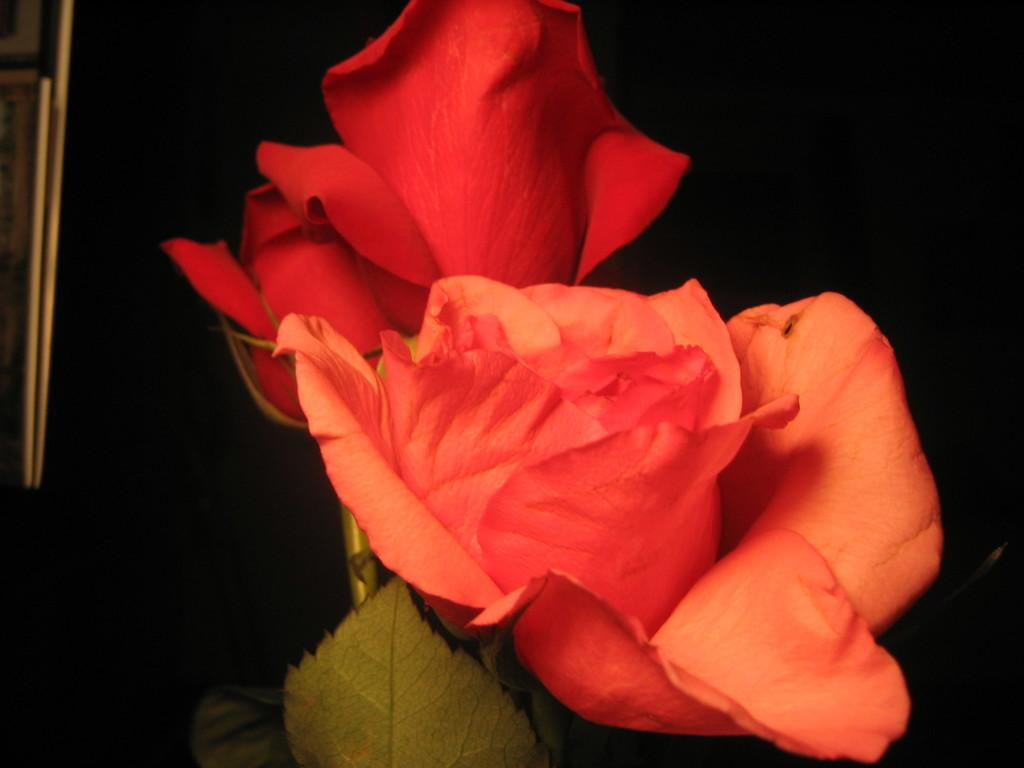What is the main subject in the center of the image? There are flowers in the center of the image. What can be seen on the left side of the image? There is a frame on the left side of the image. How would you describe the overall color scheme of the image? The background of the image is dark. What type of plot is visible in the image? There is no plot visible in the image; it features flowers and a frame. Can you see a bag in the image? There is no bag present in the image. 